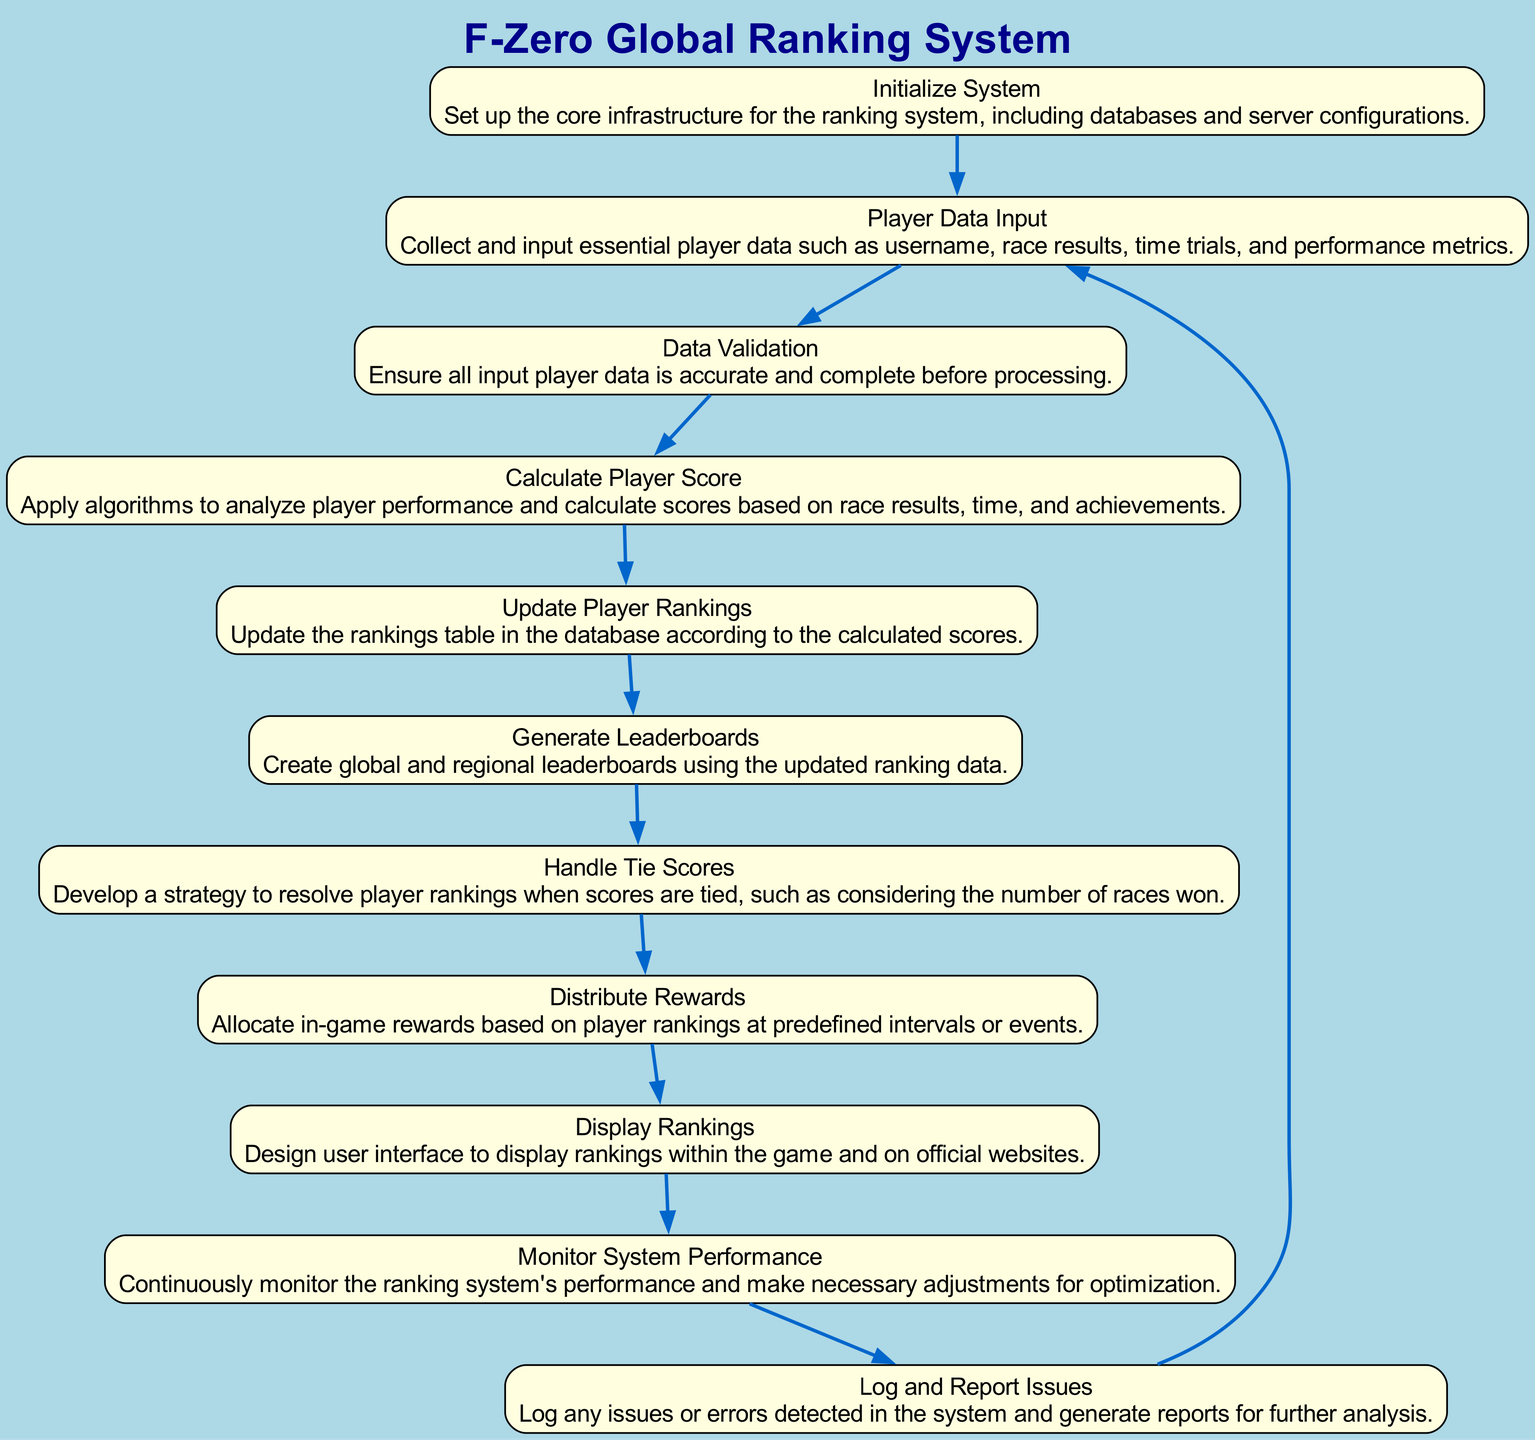What is the first step in the ranking system development? The first step as per the diagram is 'Initialize System', which indicates the setup of core infrastructure for the ranking system.
Answer: Initialize System How many total nodes are in the diagram? By counting the nodes outlined in the diagram, there are a total of 11 nodes representing different steps of the ranking system process.
Answer: 11 Which step comes after 'Calculate Player Score'? The next step after 'Calculate Player Score' is 'Update Player Rankings', indicating a sequential processing of player scores.
Answer: Update Player Rankings What type of data is validated in the 'Data Validation' step? The 'Data Validation' step focuses on ensuring that all input player data, such as race results and performance metrics, are accurate and complete.
Answer: Input player data Which node handles tie scores? The node that specifically addresses tie scores is 'Handle Tie Scores', which develops strategies to resolve tied player rankings.
Answer: Handle Tie Scores What is the final step before returning to the initial input? The final step before looping back to 'Player Data Input' is 'Log and Report Issues', indicating a feedback mechanism is in place for continuous improvement.
Answer: Log and Report Issues What step involves creating leaderboards? The step responsible for creating leaderboards is 'Generate Leaderboards', showcasing the updated ranking data both globally and regionally.
Answer: Generate Leaderboards Which node directly distributes rewards? The node that directly oversees reward allocation based on player rankings is 'Distribute Rewards', linking player performance to tangible in-game benefits.
Answer: Distribute Rewards How does the system handle performance monitoring? Performance monitoring is managed by the 'Monitor System Performance' step, which continuously oversees the ranking system's efficiency and effectiveness.
Answer: Monitor System Performance What is the purpose of the 'Display Rankings' node? The 'Display Rankings' node is designed to show the player rankings within the game and on official websites, enhancing visibility for all players.
Answer: Show player rankings 